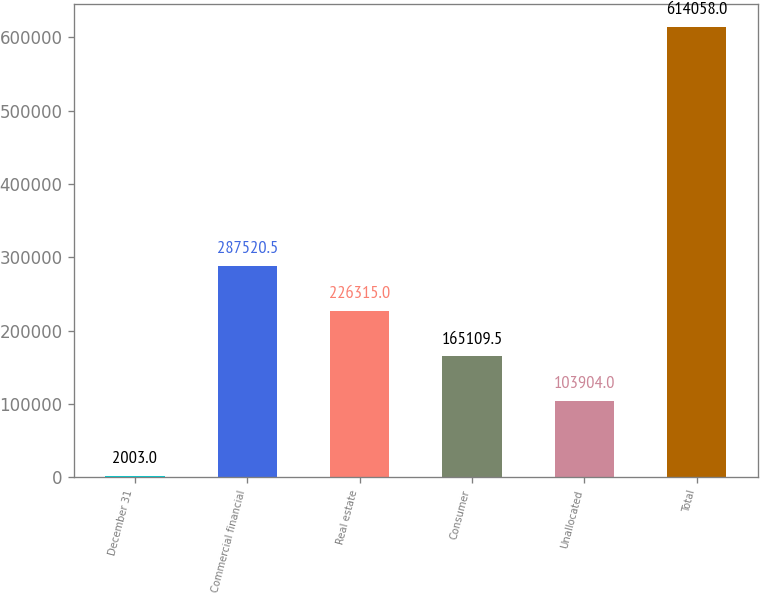Convert chart to OTSL. <chart><loc_0><loc_0><loc_500><loc_500><bar_chart><fcel>December 31<fcel>Commercial financial<fcel>Real estate<fcel>Consumer<fcel>Unallocated<fcel>Total<nl><fcel>2003<fcel>287520<fcel>226315<fcel>165110<fcel>103904<fcel>614058<nl></chart> 